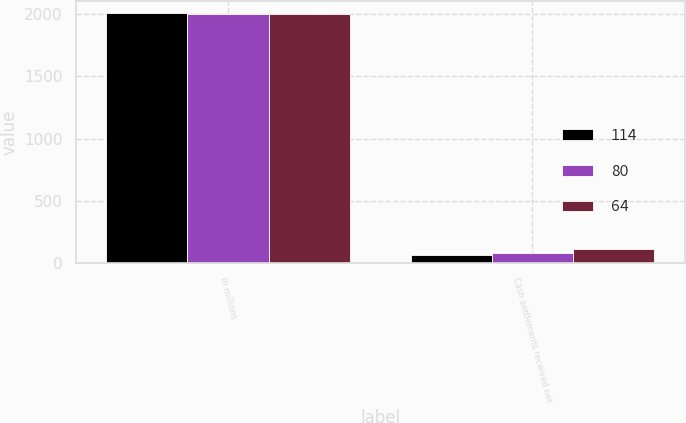Convert chart. <chart><loc_0><loc_0><loc_500><loc_500><stacked_bar_chart><ecel><fcel>In millions<fcel>Cash settlements received net<nl><fcel>114<fcel>2007<fcel>64<nl><fcel>80<fcel>2006<fcel>80<nl><fcel>64<fcel>2005<fcel>114<nl></chart> 